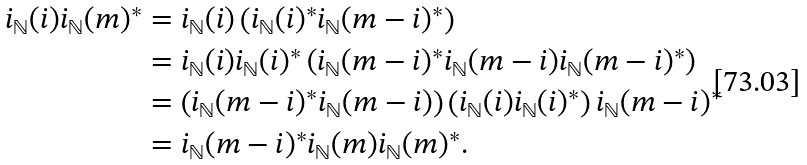Convert formula to latex. <formula><loc_0><loc_0><loc_500><loc_500>i _ { \mathbb { N } } ( i ) i _ { \mathbb { N } } ( m ) ^ { * } & = i _ { \mathbb { N } } ( i ) \left ( i _ { \mathbb { N } } ( i ) ^ { * } i _ { \mathbb { N } } ( m - i ) ^ { * } \right ) \\ & = i _ { \mathbb { N } } ( i ) i _ { \mathbb { N } } ( i ) ^ { * } \left ( i _ { \mathbb { N } } ( m - i ) ^ { * } i _ { \mathbb { N } } ( m - i ) i _ { \mathbb { N } } ( m - i ) ^ { * } \right ) \\ & = \left ( i _ { \mathbb { N } } ( m - i ) ^ { * } i _ { \mathbb { N } } ( m - i ) \right ) \left ( i _ { \mathbb { N } } ( i ) i _ { \mathbb { N } } ( i ) ^ { * } \right ) i _ { \mathbb { N } } ( m - i ) ^ { * } \\ & = i _ { \mathbb { N } } ( m - i ) ^ { * } i _ { \mathbb { N } } ( m ) i _ { \mathbb { N } } ( m ) ^ { * } .</formula> 